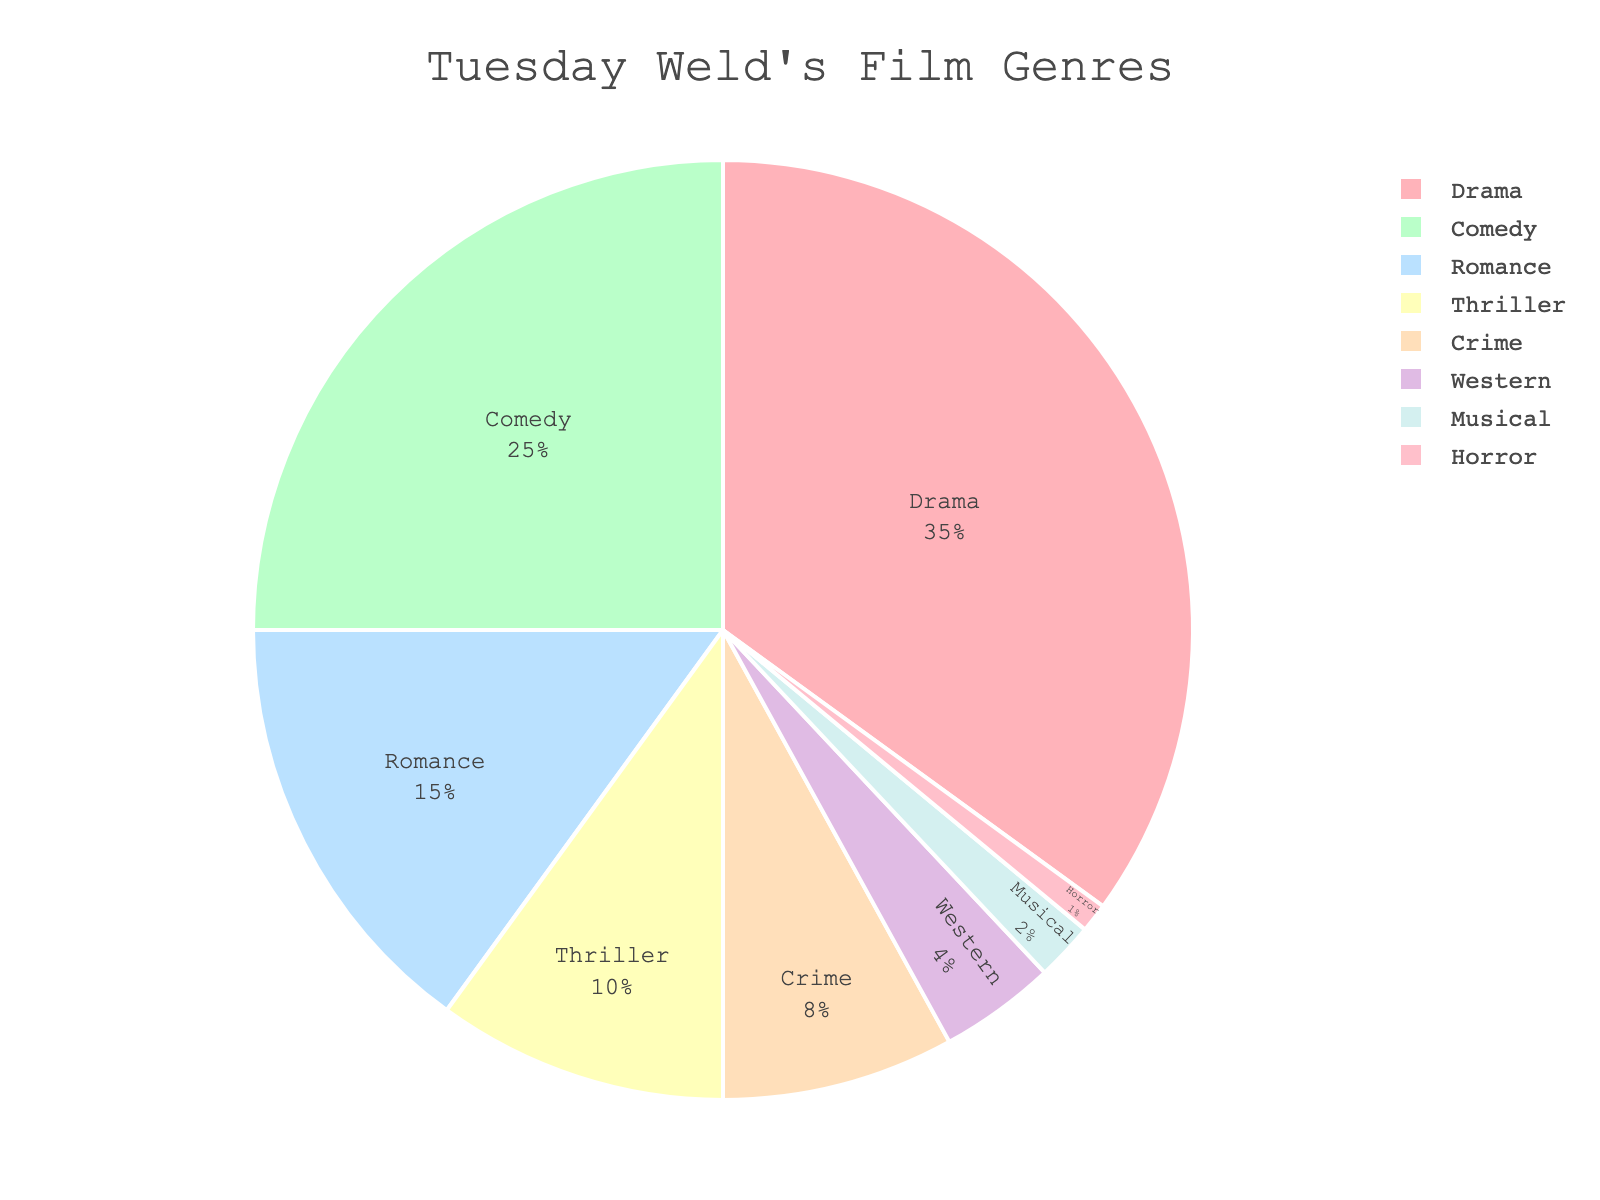What is the most frequent film genre in Tuesday Weld's career according to the figure? The largest section of the pie chart represents the most frequent film genre. The "Drama" section is the largest at 35%.
Answer: Drama Which film genre has a smaller percentage than Comedy but greater than Western? By inspecting the percentages, we see Comedy is at 25%, Western at 4%, and genres between them are Romance (15%), Thriller (10%) and Crime (8%).
Answer: Romance, Thriller, Crime What percentage of Tuesday Weld's films are either Thriller or Crime genres? Add the percentages of Thriller (10%) and Crime (8%). 10% + 8% = 18%
Answer: 18% How does the percentage of Romance films compare to the sum of Musical and Horror films? Romance is at 15%. The sum of Musical (2%) and Horror (1%) is 3%. 15% is clearly greater than 3%.
Answer: Greater than Which genre has the least representation in the pie chart and what is its percentage? The smallest section in the pie chart represents the least frequent genre. The "Horror" section is the smallest at 1%.
Answer: Horror, 1% Compare the representation of Western and Musical genres in the pie chart. Which one is larger and by how much? Western is at 4% and Musical is at 2%. Subtract 2% from 4% to find the difference: 4% - 2% = 2%.
Answer: Western, 2% Are there more films in the Comedy genre than in the combined total of Western and Horror genres? Comedy is at 25%. The combined total of Western (4%) and Horror (1%) is 5%. 25% is greater than 5%.
Answer: Yes What is the combined percentage of all the genres that have a lower percentage than Romance? Sum the percentages of genres lower than Romance (15%): Thriller (10%) + Crime (8%) + Western (4%) + Musical (2%) + Horror (1%). 10% + 8% + 4% + 2% + 1% = 25%
Answer: 25% What two genres have a combined percentage of 10% each? Looking at the pie chart, Thriller is at 10%, and no other single genre matches 10%, but individual Thriller does.
Answer: Thriller Which genre, represented by a section in blue, has a percentage of her film genres? The pie chart section colored in blue represents the "Comedy" genre at 25%.
Answer: Comedy 